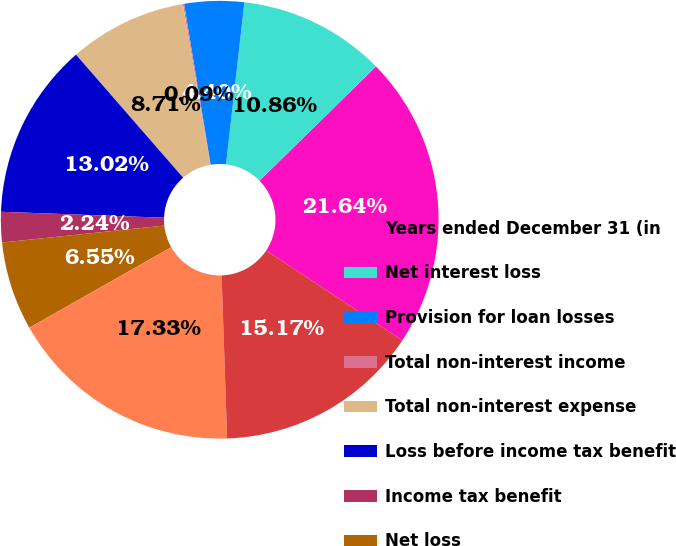<chart> <loc_0><loc_0><loc_500><loc_500><pie_chart><fcel>Years ended December 31 (in<fcel>Net interest loss<fcel>Provision for loan losses<fcel>Total non-interest income<fcel>Total non-interest expense<fcel>Loss before income tax benefit<fcel>Income tax benefit<fcel>Net loss<fcel>Average total assets<fcel>Average total liabilities<nl><fcel>21.64%<fcel>10.86%<fcel>4.4%<fcel>0.09%<fcel>8.71%<fcel>13.02%<fcel>2.24%<fcel>6.55%<fcel>17.33%<fcel>15.17%<nl></chart> 